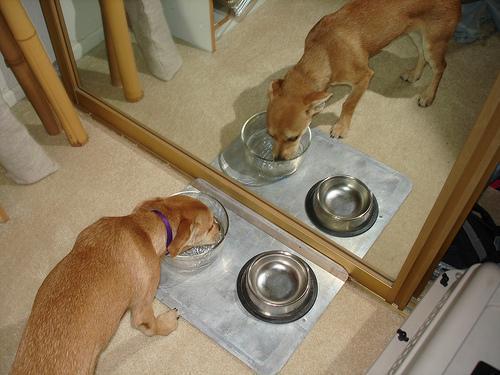How many dogs are there?
Give a very brief answer. 1. How many bowls are shown?
Give a very brief answer. 2. 